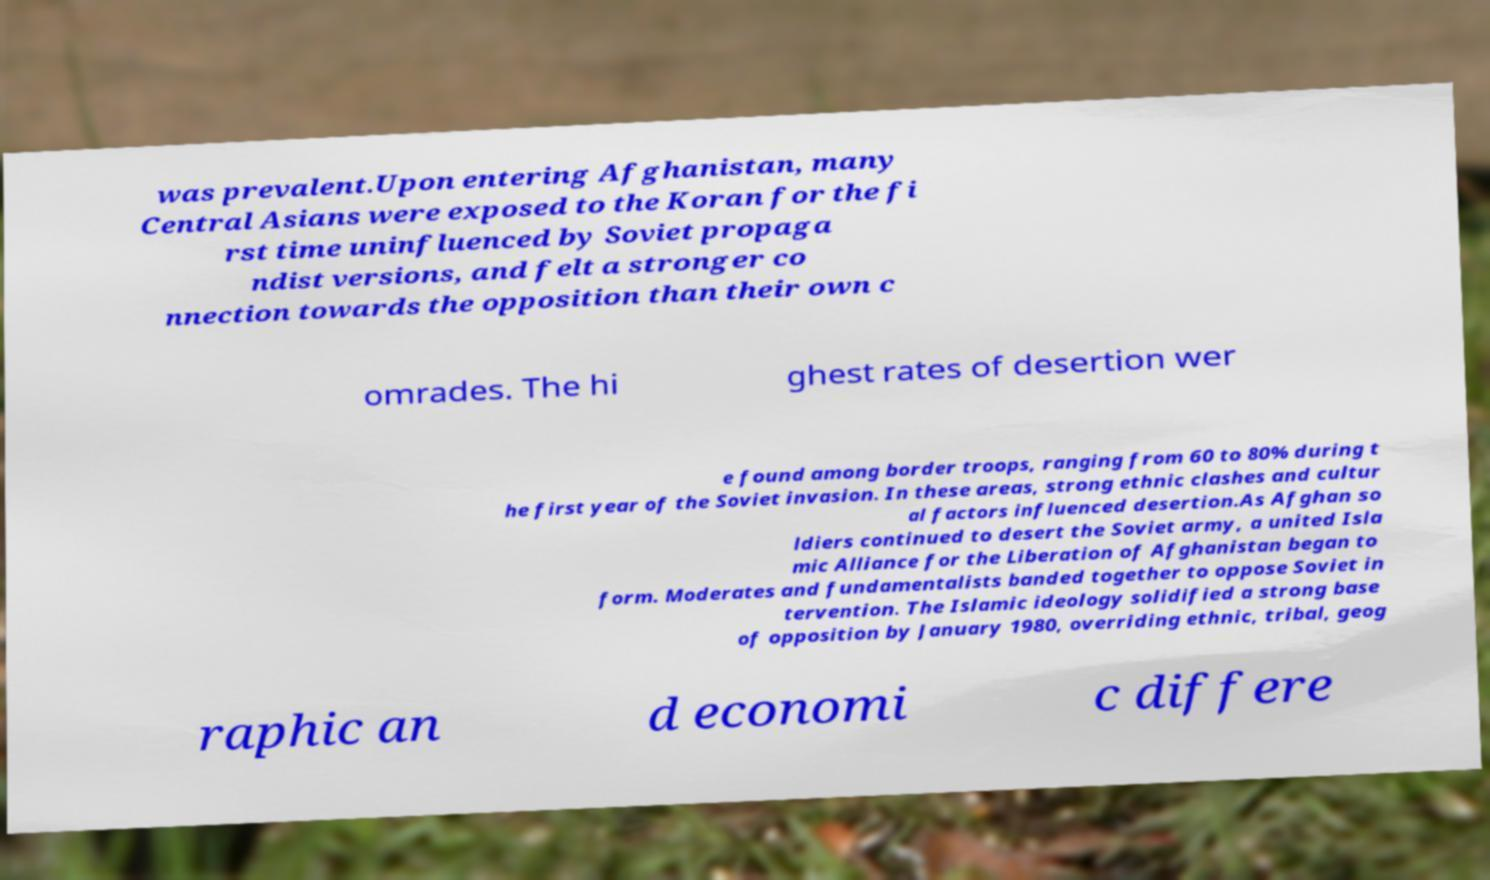Can you accurately transcribe the text from the provided image for me? was prevalent.Upon entering Afghanistan, many Central Asians were exposed to the Koran for the fi rst time uninfluenced by Soviet propaga ndist versions, and felt a stronger co nnection towards the opposition than their own c omrades. The hi ghest rates of desertion wer e found among border troops, ranging from 60 to 80% during t he first year of the Soviet invasion. In these areas, strong ethnic clashes and cultur al factors influenced desertion.As Afghan so ldiers continued to desert the Soviet army, a united Isla mic Alliance for the Liberation of Afghanistan began to form. Moderates and fundamentalists banded together to oppose Soviet in tervention. The Islamic ideology solidified a strong base of opposition by January 1980, overriding ethnic, tribal, geog raphic an d economi c differe 